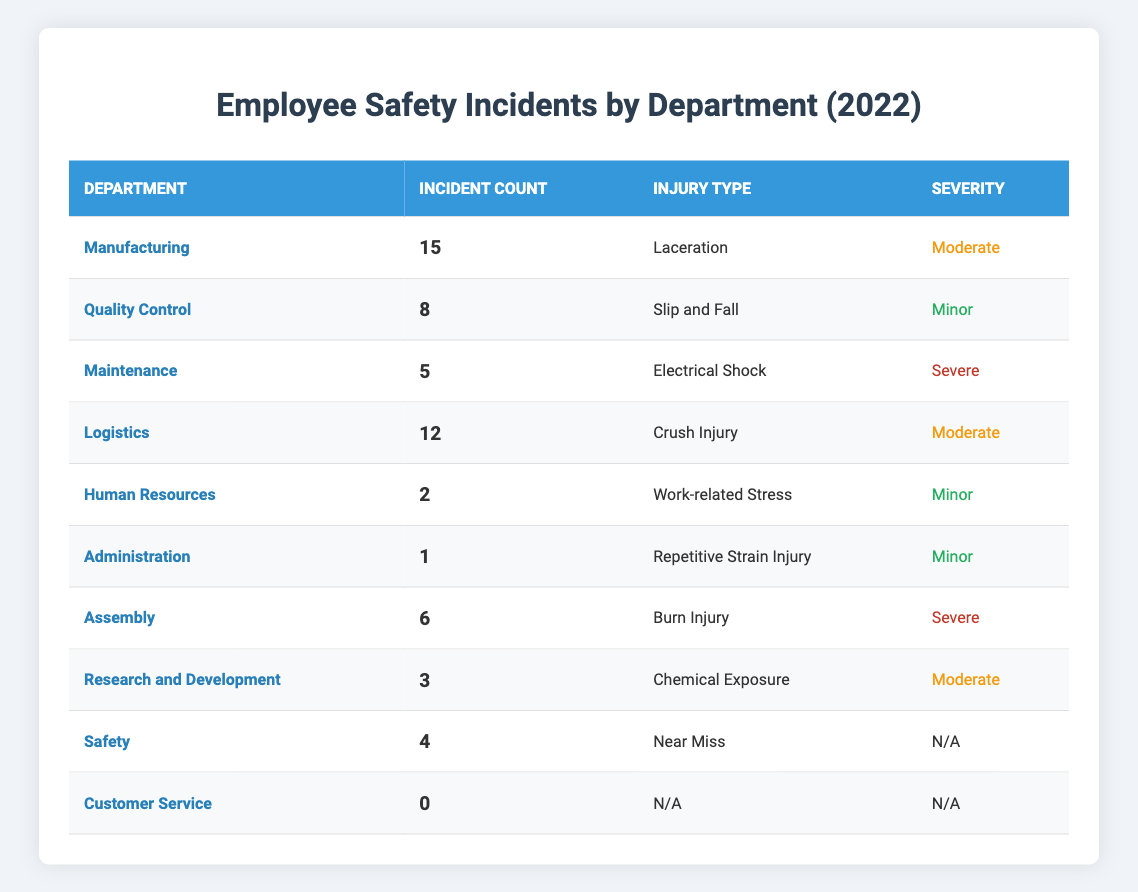What department had the highest number of safety incidents? By looking at the table, "Manufacturing" has 15 incidents, which is the highest count among all departments listed.
Answer: Manufacturing How many total safety incidents were reported across all departments? To find the total, we add the incident counts: 15 (Manufacturing) + 8 (Quality Control) + 5 (Maintenance) + 12 (Logistics) + 2 (Human Resources) + 1 (Administration) + 6 (Assembly) + 3 (Research and Development) + 4 (Safety) + 0 (Customer Service) = 52.
Answer: 52 What is the severity of the incident that occurred in the Maintenance department? According to the table, the incident in the Maintenance department is classified as "Severe".
Answer: Severe Did any department have zero safety incidents? Yes, the "Customer Service" department reported 0 incidents, as shown in the table.
Answer: Yes Which department had the most severe type of incident? The "Maintenance" and "Assembly" departments both had incidents categorized as "Severe", but Maintenance had only one incident while Assembly had six, indicating that although both are classified as severe, the comparison is about total incidents.
Answer: Maintenance and Assembly What is the average number of incidents per department? There are 10 departments listed. The total number of incidents is 52. To find the average, divide 52 by 10: 52/10 = 5.2.
Answer: 5.2 How many incidents classified as "Minor" occurred in total? In the table, the following departments had minor incidents: Quality Control (8) + Human Resources (2) + Administration (1) = 11.
Answer: 11 Is it true that the Logistics department had more incidents than Quality Control? Yes, Logistics had 12 incidents while Quality Control had 8, making the statement true.
Answer: True Which department had the least number of incidents? The "Administration" department reported only 1 incident, which is the lowest count among all departments.
Answer: Administration If we exclude the departments with no incidents, what is the incident count for departments that reported incidents? The departments with incidents are Manufacturing (15), Quality Control (8), Maintenance (5), Logistics (12), Human Resources (2), Assembly (6), Research and Development (3), and Safety (4). Adding these together gives: 15 + 8 + 5 + 12 + 2 + 6 + 3 + 4 = 55.
Answer: 55 